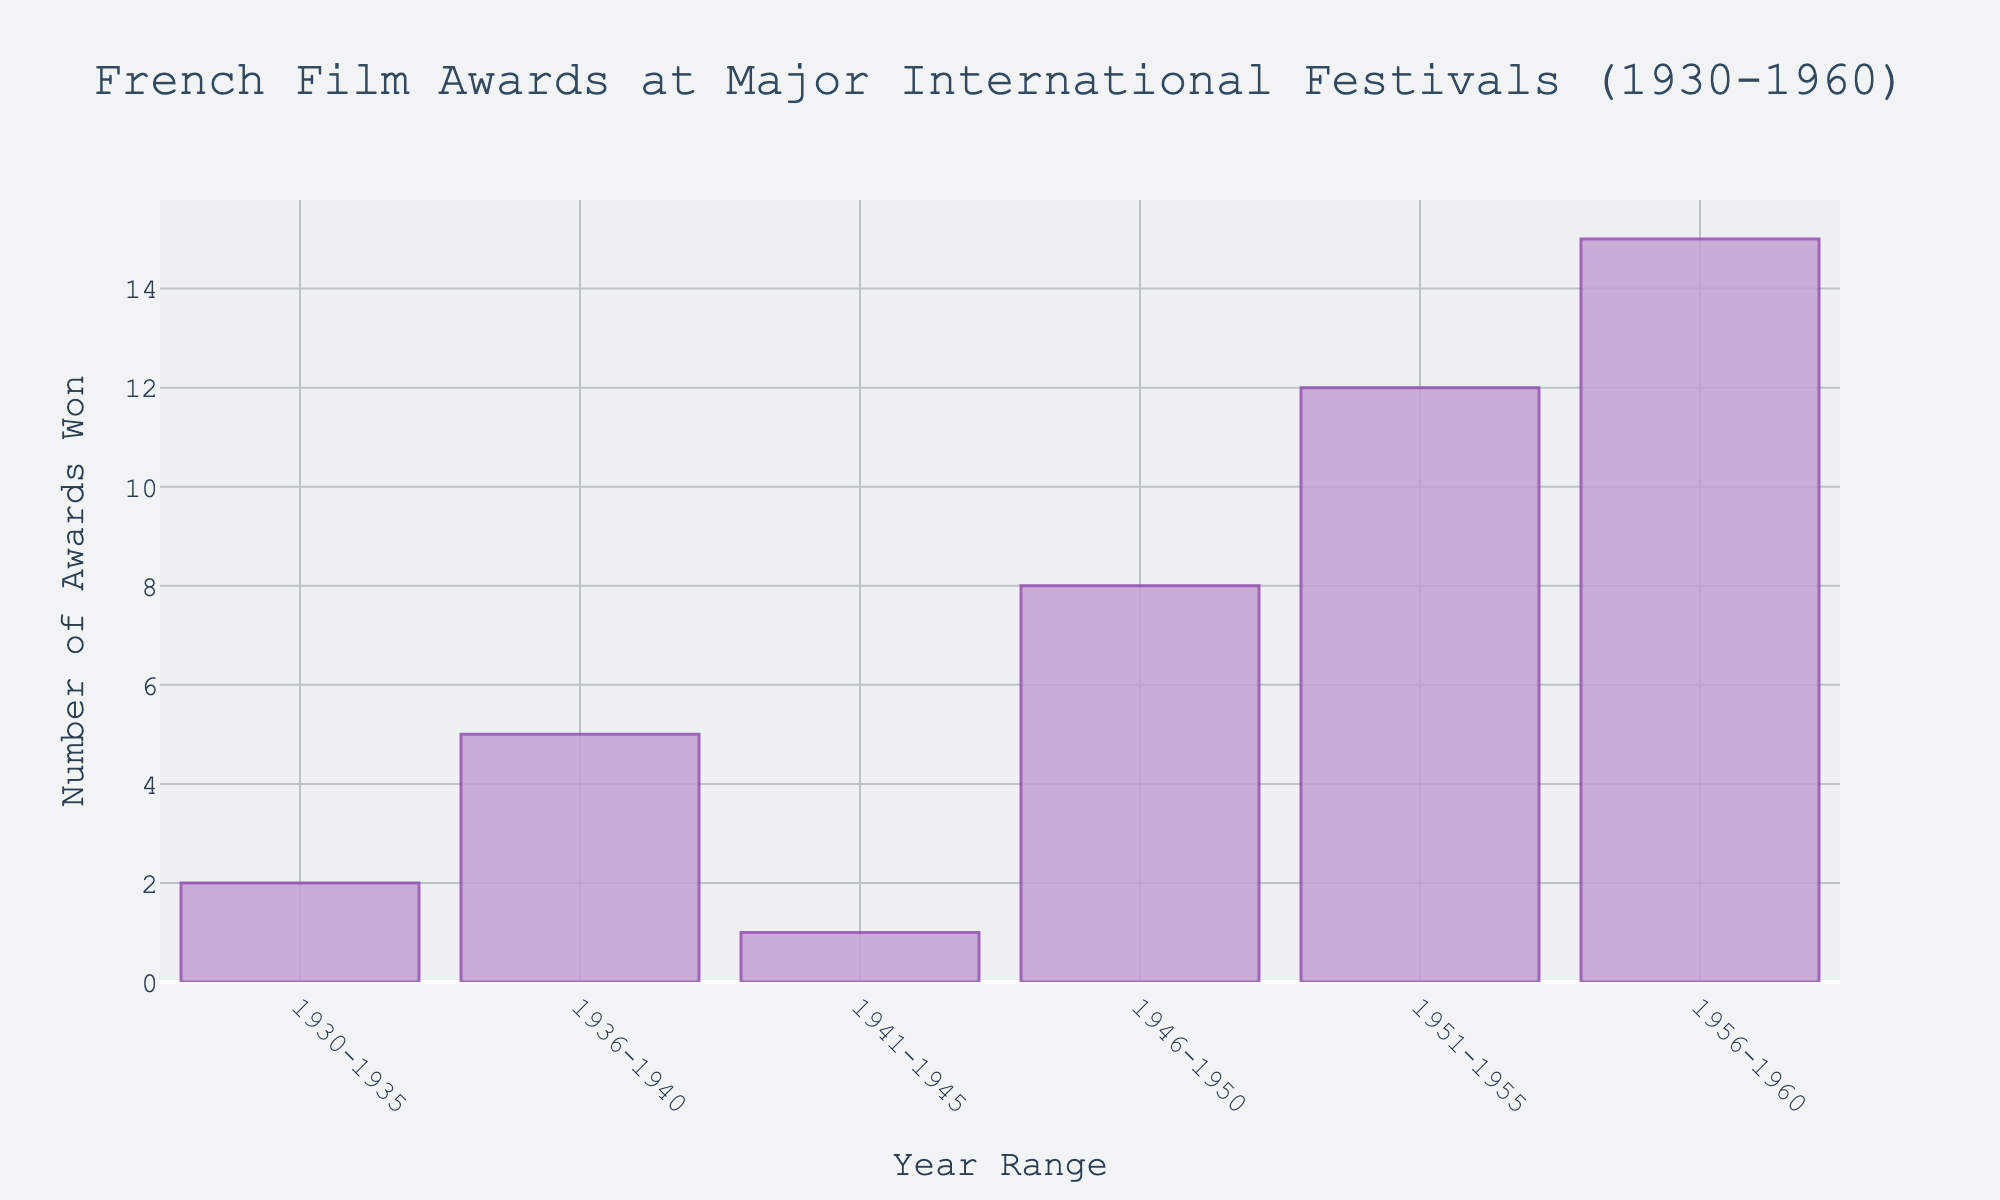What is the title of the figure? The title is presented at the top of the figure and summarizes what the chart is about: "French Film Awards at Major International Festivals (1930-1960)"
Answer: French Film Awards at Major International Festivals (1930-1960) How many different year ranges are shown in the figure? To find the number of different year ranges, count the distinct entries on the x-axis.
Answer: 6 Which year range had the highest number of awards won? Identify the bar with the greatest height, which corresponds to the highest number of awards.
Answer: 1956-1960 What is the number of awards won during 1930-1935? Locate the bar representing the 1930-1935 year range and check its height to determine the number of awards.
Answer: 2 How many total awards were won between 1930 and 1940? Sum the number of awards won in the year ranges 1930-1935 and 1936-1940. That is 2 + 5.
Answer: 7 What is the difference in the number of awards between 1941-1945 and 1951-1955? Subtract the number of awards in 1941-1945 from those in 1951-1955. That is 12 - 1.
Answer: 11 What is the general trend in the number of awards won from 1930 to 1960? Observe the heights of the bars from left to right to determine if there is an increasing, decreasing, or fluctuating trend.
Answer: Increasing How many awards were won on average per year range? Sum all the awards and divide by the number of year ranges. That is (2 + 5 + 1 + 8 + 12 + 15) / 6.
Answer: 7.167 What is the combined total of awards won from 1946 to 1960? Add the awards from the year ranges 1946-1950, 1951-1955, and 1956-1960. That is 8 + 12 + 15.
Answer: 35 Which decade saw the greatest increase in awards? Compare the difference in awards won from one decade to the next. Calculate the differences (5 - 2), (1 - 5), (8 - 1), (12 - 8), and (15 - 12) to determine the greatest increase.
Answer: 1940s 